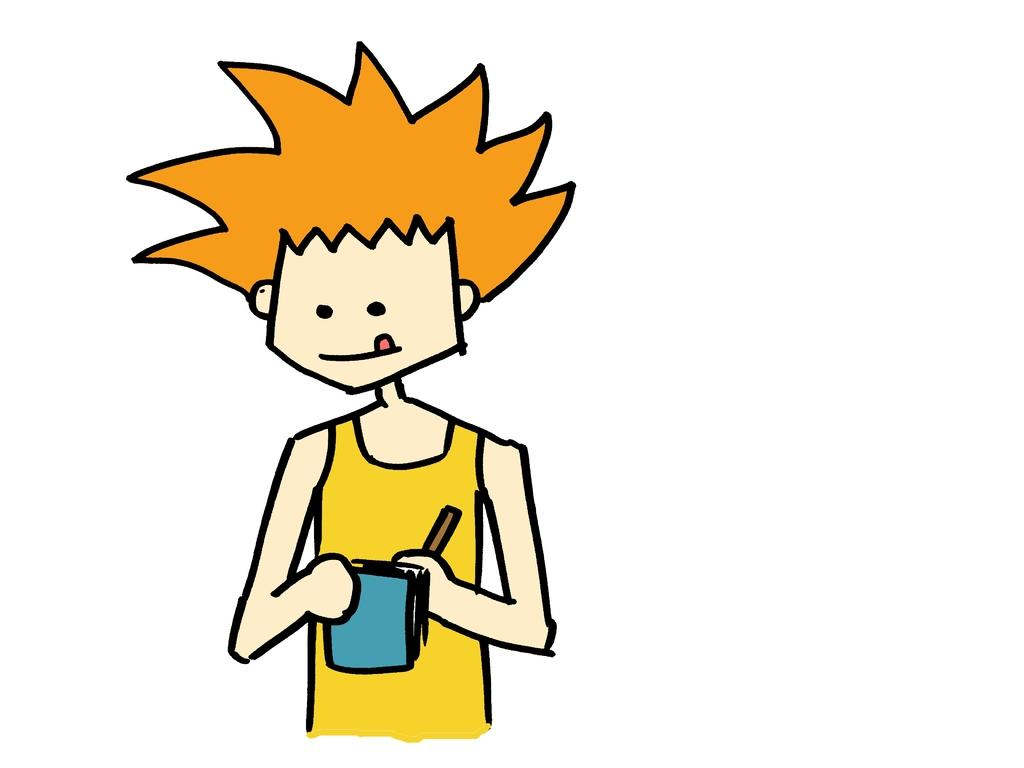What style is the image in? The image is a cartoon. Can you describe the person in the image? There is a person in the image. What is the person holding in his hands? The person is holding a cup and another object. What type of dress is the person wearing in the image? The image is a cartoon, and the person is not wearing a dress; they are likely wearing cartoonish clothing. Can you read the letter the person is holding in the image? There is no letter present in the image; the person is holding a cup and another object. 